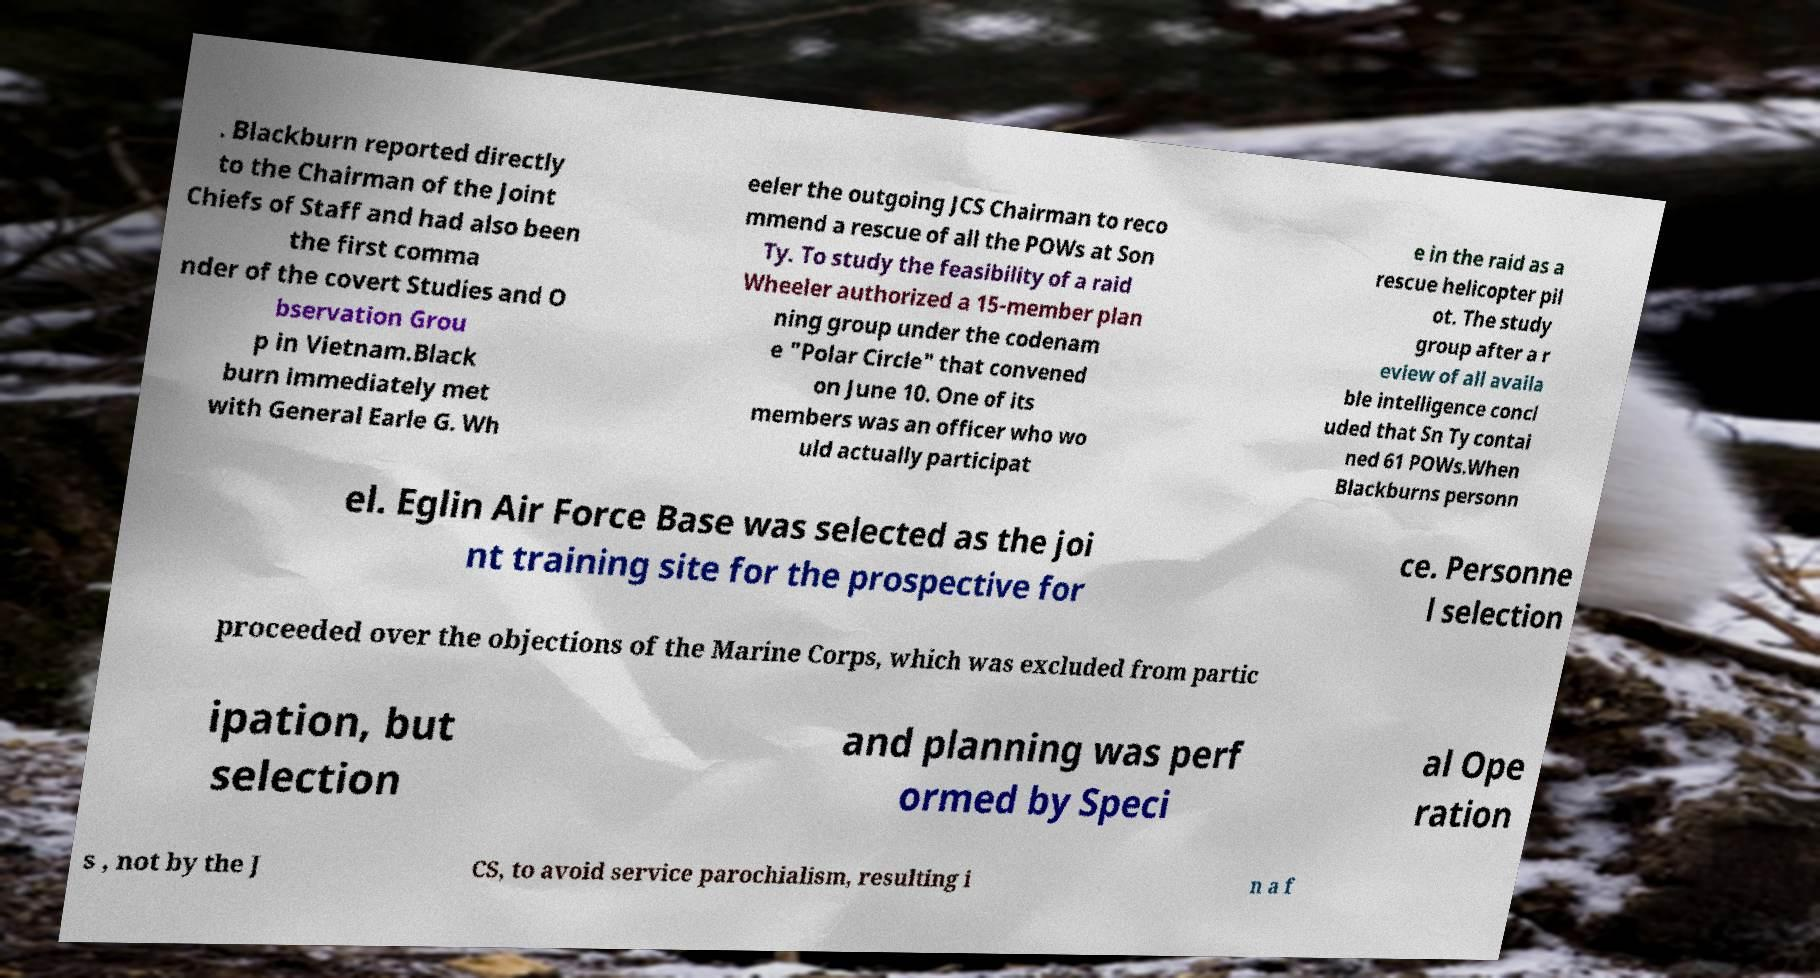I need the written content from this picture converted into text. Can you do that? . Blackburn reported directly to the Chairman of the Joint Chiefs of Staff and had also been the first comma nder of the covert Studies and O bservation Grou p in Vietnam.Black burn immediately met with General Earle G. Wh eeler the outgoing JCS Chairman to reco mmend a rescue of all the POWs at Son Ty. To study the feasibility of a raid Wheeler authorized a 15-member plan ning group under the codenam e "Polar Circle" that convened on June 10. One of its members was an officer who wo uld actually participat e in the raid as a rescue helicopter pil ot. The study group after a r eview of all availa ble intelligence concl uded that Sn Ty contai ned 61 POWs.When Blackburns personn el. Eglin Air Force Base was selected as the joi nt training site for the prospective for ce. Personne l selection proceeded over the objections of the Marine Corps, which was excluded from partic ipation, but selection and planning was perf ormed by Speci al Ope ration s , not by the J CS, to avoid service parochialism, resulting i n a f 